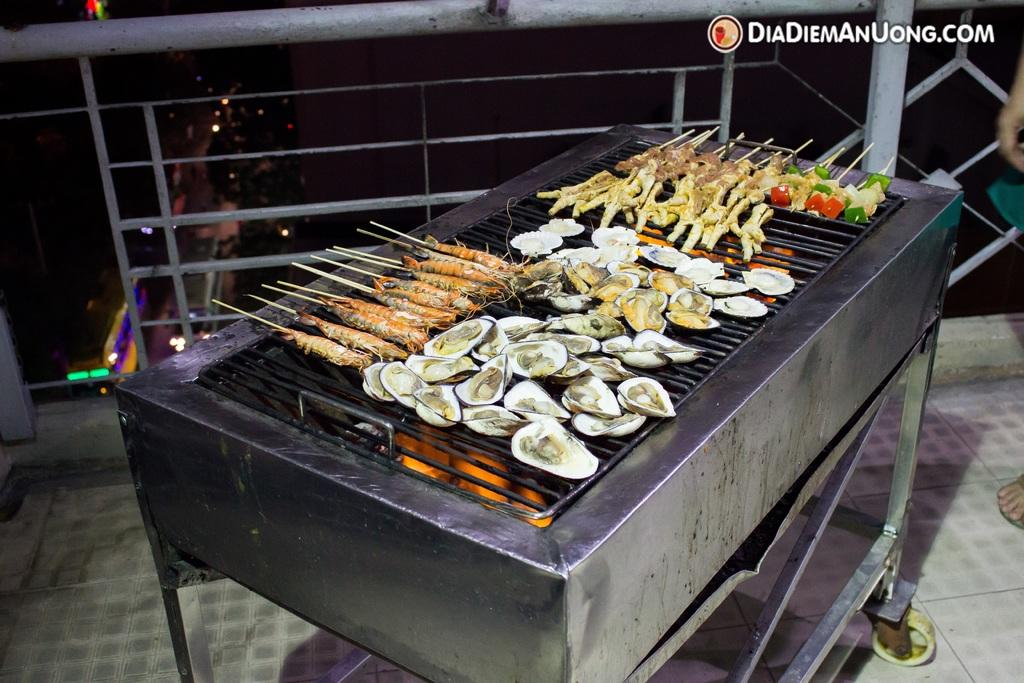<image>
Give a short and clear explanation of the subsequent image. some different items cooking with diadiemanuong.com on it 